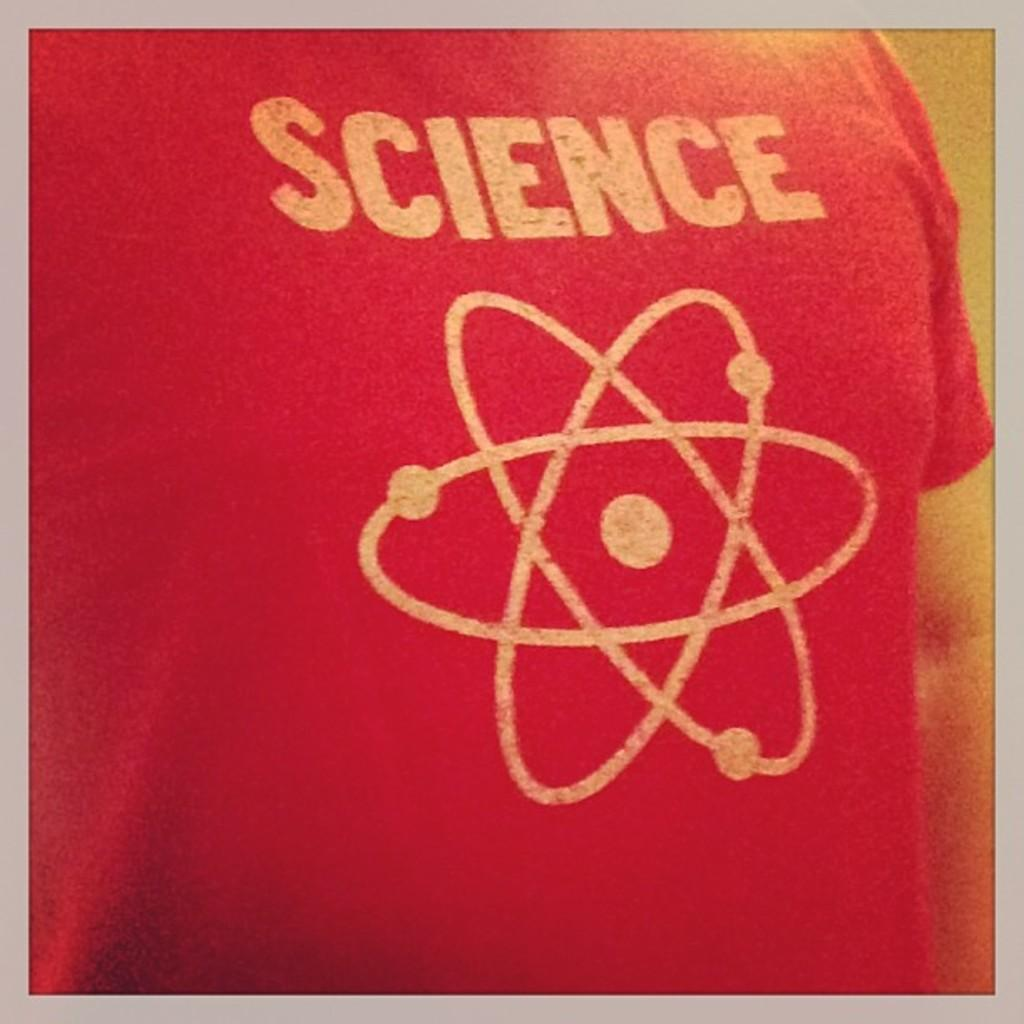<image>
Render a clear and concise summary of the photo. A red shirt that says Science on it in white lettering. 